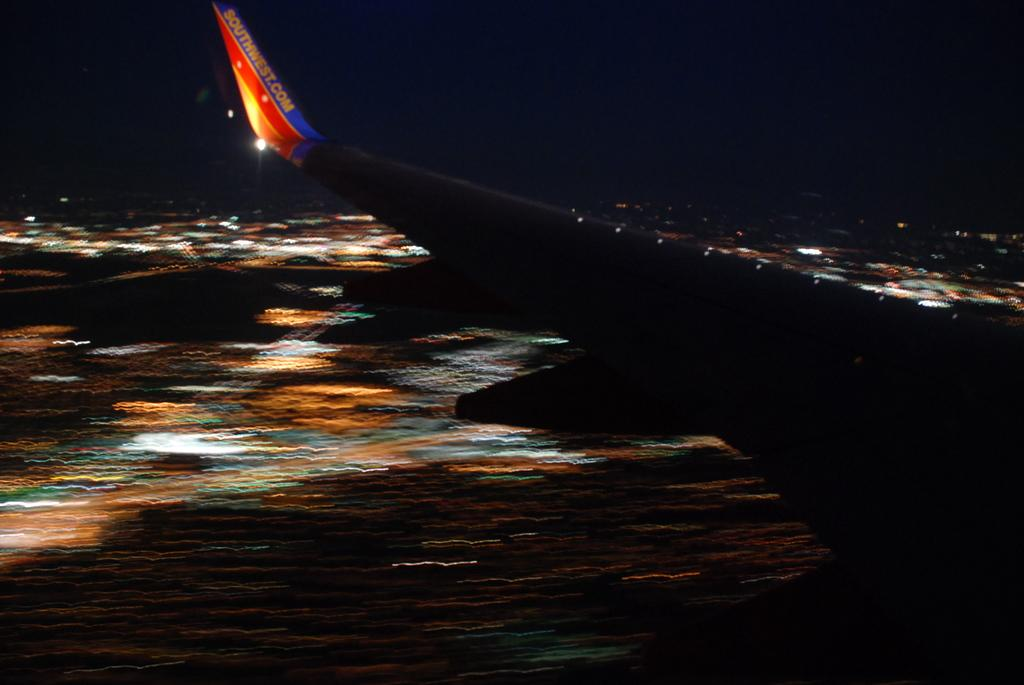Provide a one-sentence caption for the provided image. a blurred landing of a Southwest flight where only the wing is visible. 